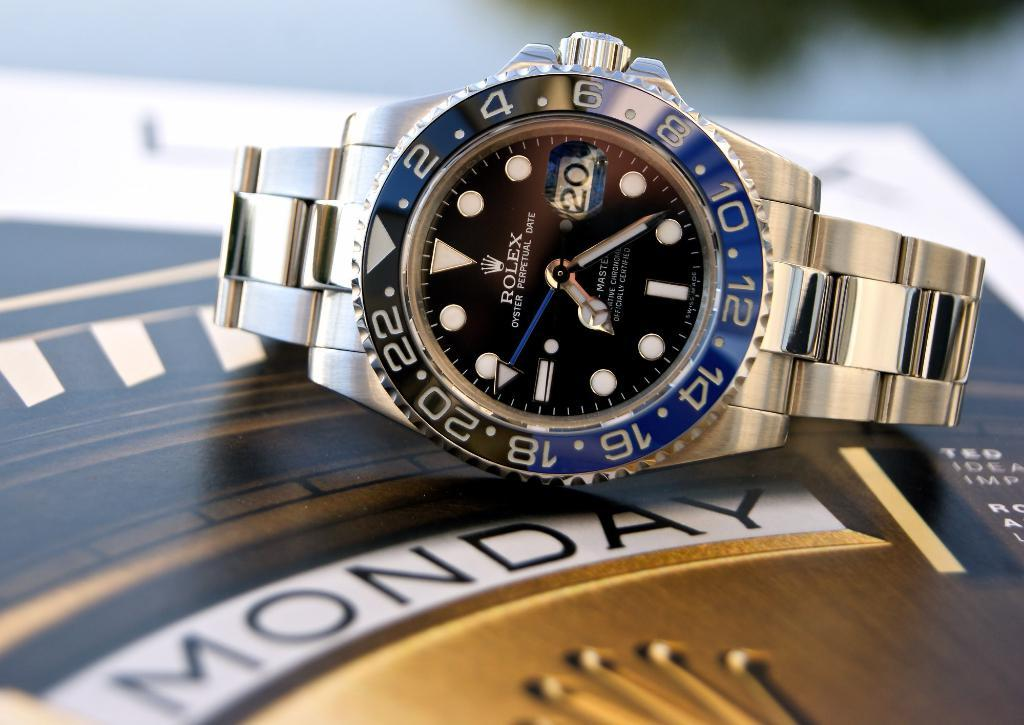What object can be seen on someone's wrist in the image? There is a wrist watch in the image. What else is present in the image besides the wrist watch? There is a poster in the image. Can you describe the background of the image? The background of the image is blurred. What type of coal is being used to fuel the fire in the image? There is no fire or coal present in the image; it only features a wrist watch and a poster. 